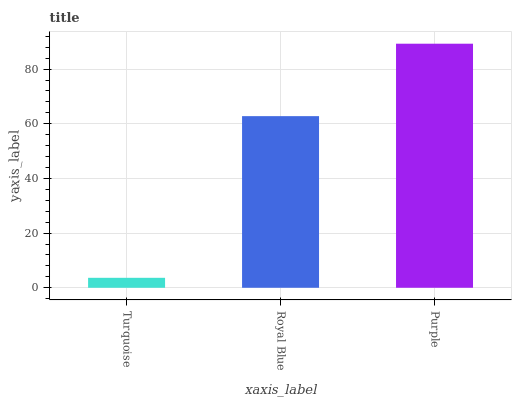Is Royal Blue the minimum?
Answer yes or no. No. Is Royal Blue the maximum?
Answer yes or no. No. Is Royal Blue greater than Turquoise?
Answer yes or no. Yes. Is Turquoise less than Royal Blue?
Answer yes or no. Yes. Is Turquoise greater than Royal Blue?
Answer yes or no. No. Is Royal Blue less than Turquoise?
Answer yes or no. No. Is Royal Blue the high median?
Answer yes or no. Yes. Is Royal Blue the low median?
Answer yes or no. Yes. Is Purple the high median?
Answer yes or no. No. Is Turquoise the low median?
Answer yes or no. No. 